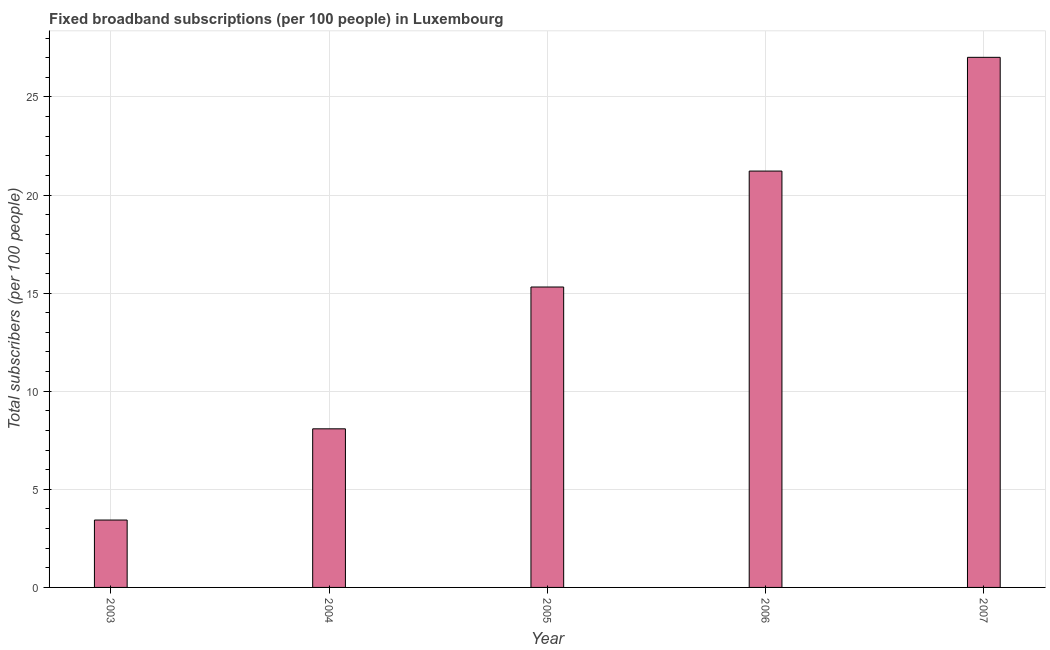Does the graph contain grids?
Make the answer very short. Yes. What is the title of the graph?
Your answer should be compact. Fixed broadband subscriptions (per 100 people) in Luxembourg. What is the label or title of the X-axis?
Offer a terse response. Year. What is the label or title of the Y-axis?
Provide a short and direct response. Total subscribers (per 100 people). What is the total number of fixed broadband subscriptions in 2004?
Offer a terse response. 8.08. Across all years, what is the maximum total number of fixed broadband subscriptions?
Offer a terse response. 27.02. Across all years, what is the minimum total number of fixed broadband subscriptions?
Keep it short and to the point. 3.43. In which year was the total number of fixed broadband subscriptions minimum?
Your response must be concise. 2003. What is the sum of the total number of fixed broadband subscriptions?
Your response must be concise. 75.07. What is the difference between the total number of fixed broadband subscriptions in 2004 and 2007?
Ensure brevity in your answer.  -18.93. What is the average total number of fixed broadband subscriptions per year?
Keep it short and to the point. 15.01. What is the median total number of fixed broadband subscriptions?
Offer a terse response. 15.31. In how many years, is the total number of fixed broadband subscriptions greater than 11 ?
Offer a terse response. 3. What is the ratio of the total number of fixed broadband subscriptions in 2004 to that in 2006?
Your response must be concise. 0.38. What is the difference between the highest and the second highest total number of fixed broadband subscriptions?
Offer a very short reply. 5.8. What is the difference between the highest and the lowest total number of fixed broadband subscriptions?
Make the answer very short. 23.58. Are all the bars in the graph horizontal?
Provide a succinct answer. No. How many years are there in the graph?
Make the answer very short. 5. What is the difference between two consecutive major ticks on the Y-axis?
Offer a very short reply. 5. Are the values on the major ticks of Y-axis written in scientific E-notation?
Offer a terse response. No. What is the Total subscribers (per 100 people) in 2003?
Your answer should be very brief. 3.43. What is the Total subscribers (per 100 people) in 2004?
Your response must be concise. 8.08. What is the Total subscribers (per 100 people) in 2005?
Make the answer very short. 15.31. What is the Total subscribers (per 100 people) of 2006?
Offer a terse response. 21.22. What is the Total subscribers (per 100 people) of 2007?
Your response must be concise. 27.02. What is the difference between the Total subscribers (per 100 people) in 2003 and 2004?
Make the answer very short. -4.65. What is the difference between the Total subscribers (per 100 people) in 2003 and 2005?
Your answer should be very brief. -11.88. What is the difference between the Total subscribers (per 100 people) in 2003 and 2006?
Give a very brief answer. -17.79. What is the difference between the Total subscribers (per 100 people) in 2003 and 2007?
Ensure brevity in your answer.  -23.58. What is the difference between the Total subscribers (per 100 people) in 2004 and 2005?
Your answer should be very brief. -7.23. What is the difference between the Total subscribers (per 100 people) in 2004 and 2006?
Your response must be concise. -13.14. What is the difference between the Total subscribers (per 100 people) in 2004 and 2007?
Your response must be concise. -18.93. What is the difference between the Total subscribers (per 100 people) in 2005 and 2006?
Your response must be concise. -5.91. What is the difference between the Total subscribers (per 100 people) in 2005 and 2007?
Your answer should be compact. -11.71. What is the difference between the Total subscribers (per 100 people) in 2006 and 2007?
Make the answer very short. -5.8. What is the ratio of the Total subscribers (per 100 people) in 2003 to that in 2004?
Offer a terse response. 0.42. What is the ratio of the Total subscribers (per 100 people) in 2003 to that in 2005?
Give a very brief answer. 0.22. What is the ratio of the Total subscribers (per 100 people) in 2003 to that in 2006?
Ensure brevity in your answer.  0.16. What is the ratio of the Total subscribers (per 100 people) in 2003 to that in 2007?
Provide a short and direct response. 0.13. What is the ratio of the Total subscribers (per 100 people) in 2004 to that in 2005?
Give a very brief answer. 0.53. What is the ratio of the Total subscribers (per 100 people) in 2004 to that in 2006?
Your answer should be compact. 0.38. What is the ratio of the Total subscribers (per 100 people) in 2004 to that in 2007?
Provide a succinct answer. 0.3. What is the ratio of the Total subscribers (per 100 people) in 2005 to that in 2006?
Offer a very short reply. 0.72. What is the ratio of the Total subscribers (per 100 people) in 2005 to that in 2007?
Ensure brevity in your answer.  0.57. What is the ratio of the Total subscribers (per 100 people) in 2006 to that in 2007?
Give a very brief answer. 0.79. 